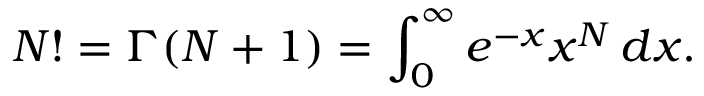<formula> <loc_0><loc_0><loc_500><loc_500>N ! = \Gamma ( N + 1 ) = \int _ { 0 } ^ { \infty } e ^ { - x } x ^ { N } \, d x .</formula> 